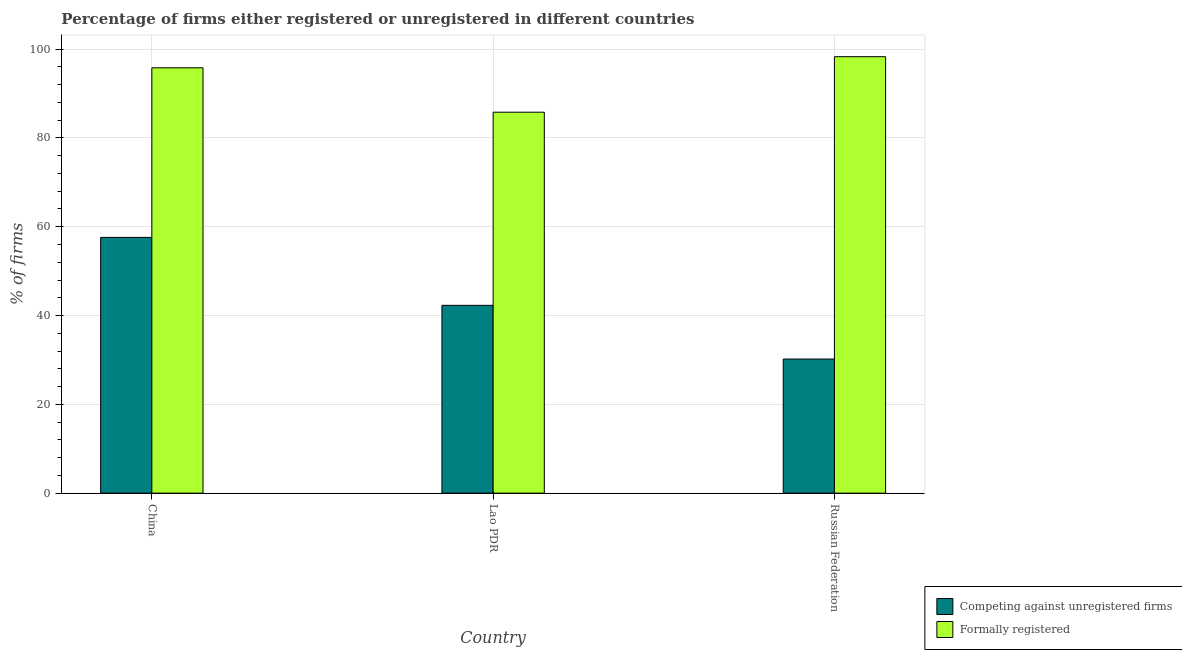How many groups of bars are there?
Provide a succinct answer. 3. What is the label of the 3rd group of bars from the left?
Your answer should be very brief. Russian Federation. What is the percentage of registered firms in Lao PDR?
Your response must be concise. 42.3. Across all countries, what is the maximum percentage of registered firms?
Make the answer very short. 57.6. Across all countries, what is the minimum percentage of formally registered firms?
Your response must be concise. 85.8. In which country was the percentage of formally registered firms minimum?
Give a very brief answer. Lao PDR. What is the total percentage of registered firms in the graph?
Make the answer very short. 130.1. What is the difference between the percentage of registered firms in China and that in Russian Federation?
Your response must be concise. 27.4. What is the difference between the percentage of formally registered firms in China and the percentage of registered firms in Russian Federation?
Offer a very short reply. 65.6. What is the average percentage of registered firms per country?
Offer a very short reply. 43.37. What is the difference between the percentage of registered firms and percentage of formally registered firms in Lao PDR?
Your answer should be very brief. -43.5. What is the ratio of the percentage of formally registered firms in China to that in Russian Federation?
Your answer should be compact. 0.97. Is the percentage of registered firms in China less than that in Russian Federation?
Offer a terse response. No. Is the difference between the percentage of registered firms in Lao PDR and Russian Federation greater than the difference between the percentage of formally registered firms in Lao PDR and Russian Federation?
Your response must be concise. Yes. What is the difference between the highest and the second highest percentage of formally registered firms?
Keep it short and to the point. 2.5. What is the difference between the highest and the lowest percentage of formally registered firms?
Your response must be concise. 12.5. In how many countries, is the percentage of registered firms greater than the average percentage of registered firms taken over all countries?
Your answer should be compact. 1. Is the sum of the percentage of registered firms in China and Lao PDR greater than the maximum percentage of formally registered firms across all countries?
Provide a succinct answer. Yes. What does the 1st bar from the left in China represents?
Offer a terse response. Competing against unregistered firms. What does the 1st bar from the right in China represents?
Provide a succinct answer. Formally registered. How many bars are there?
Offer a very short reply. 6. Are all the bars in the graph horizontal?
Offer a terse response. No. How many countries are there in the graph?
Ensure brevity in your answer.  3. What is the difference between two consecutive major ticks on the Y-axis?
Your response must be concise. 20. Where does the legend appear in the graph?
Provide a succinct answer. Bottom right. What is the title of the graph?
Make the answer very short. Percentage of firms either registered or unregistered in different countries. Does "Exports of goods" appear as one of the legend labels in the graph?
Your answer should be very brief. No. What is the label or title of the Y-axis?
Make the answer very short. % of firms. What is the % of firms of Competing against unregistered firms in China?
Ensure brevity in your answer.  57.6. What is the % of firms of Formally registered in China?
Keep it short and to the point. 95.8. What is the % of firms of Competing against unregistered firms in Lao PDR?
Make the answer very short. 42.3. What is the % of firms of Formally registered in Lao PDR?
Ensure brevity in your answer.  85.8. What is the % of firms of Competing against unregistered firms in Russian Federation?
Your response must be concise. 30.2. What is the % of firms in Formally registered in Russian Federation?
Your response must be concise. 98.3. Across all countries, what is the maximum % of firms in Competing against unregistered firms?
Keep it short and to the point. 57.6. Across all countries, what is the maximum % of firms in Formally registered?
Offer a very short reply. 98.3. Across all countries, what is the minimum % of firms in Competing against unregistered firms?
Provide a succinct answer. 30.2. Across all countries, what is the minimum % of firms in Formally registered?
Give a very brief answer. 85.8. What is the total % of firms in Competing against unregistered firms in the graph?
Give a very brief answer. 130.1. What is the total % of firms of Formally registered in the graph?
Keep it short and to the point. 279.9. What is the difference between the % of firms in Competing against unregistered firms in China and that in Lao PDR?
Your answer should be very brief. 15.3. What is the difference between the % of firms in Competing against unregistered firms in China and that in Russian Federation?
Keep it short and to the point. 27.4. What is the difference between the % of firms in Competing against unregistered firms in Lao PDR and that in Russian Federation?
Provide a succinct answer. 12.1. What is the difference between the % of firms in Competing against unregistered firms in China and the % of firms in Formally registered in Lao PDR?
Give a very brief answer. -28.2. What is the difference between the % of firms in Competing against unregistered firms in China and the % of firms in Formally registered in Russian Federation?
Keep it short and to the point. -40.7. What is the difference between the % of firms of Competing against unregistered firms in Lao PDR and the % of firms of Formally registered in Russian Federation?
Ensure brevity in your answer.  -56. What is the average % of firms of Competing against unregistered firms per country?
Your response must be concise. 43.37. What is the average % of firms in Formally registered per country?
Your answer should be compact. 93.3. What is the difference between the % of firms in Competing against unregistered firms and % of firms in Formally registered in China?
Provide a short and direct response. -38.2. What is the difference between the % of firms in Competing against unregistered firms and % of firms in Formally registered in Lao PDR?
Your response must be concise. -43.5. What is the difference between the % of firms in Competing against unregistered firms and % of firms in Formally registered in Russian Federation?
Your answer should be very brief. -68.1. What is the ratio of the % of firms in Competing against unregistered firms in China to that in Lao PDR?
Ensure brevity in your answer.  1.36. What is the ratio of the % of firms in Formally registered in China to that in Lao PDR?
Your response must be concise. 1.12. What is the ratio of the % of firms in Competing against unregistered firms in China to that in Russian Federation?
Offer a very short reply. 1.91. What is the ratio of the % of firms of Formally registered in China to that in Russian Federation?
Ensure brevity in your answer.  0.97. What is the ratio of the % of firms of Competing against unregistered firms in Lao PDR to that in Russian Federation?
Offer a terse response. 1.4. What is the ratio of the % of firms in Formally registered in Lao PDR to that in Russian Federation?
Keep it short and to the point. 0.87. What is the difference between the highest and the lowest % of firms of Competing against unregistered firms?
Ensure brevity in your answer.  27.4. What is the difference between the highest and the lowest % of firms of Formally registered?
Give a very brief answer. 12.5. 